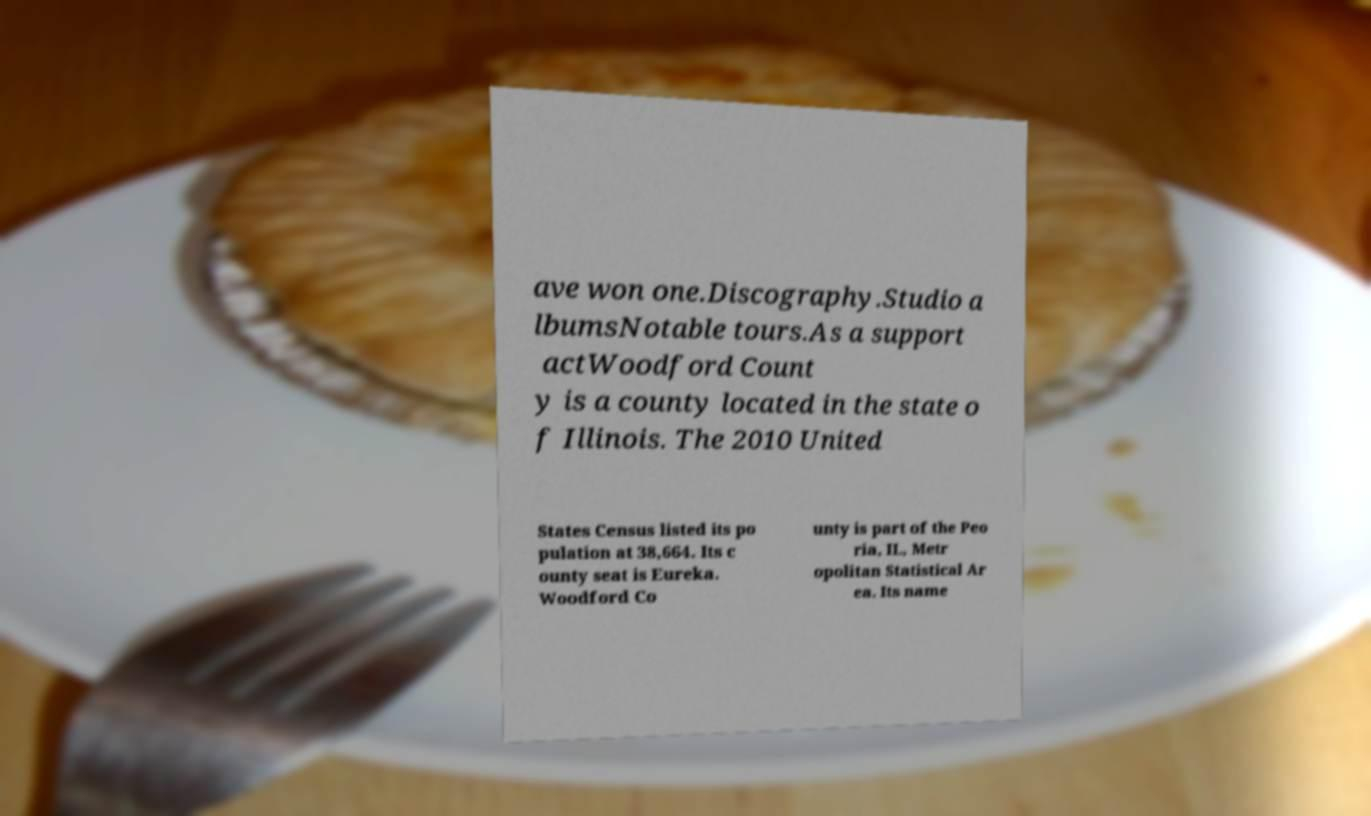Can you read and provide the text displayed in the image?This photo seems to have some interesting text. Can you extract and type it out for me? ave won one.Discography.Studio a lbumsNotable tours.As a support actWoodford Count y is a county located in the state o f Illinois. The 2010 United States Census listed its po pulation at 38,664. Its c ounty seat is Eureka. Woodford Co unty is part of the Peo ria, IL, Metr opolitan Statistical Ar ea. Its name 